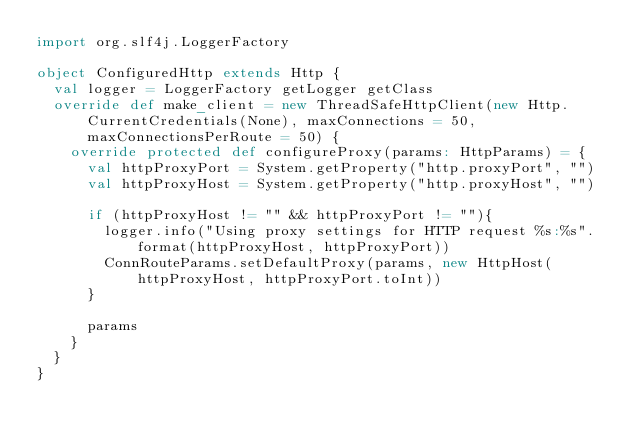Convert code to text. <code><loc_0><loc_0><loc_500><loc_500><_Scala_>import org.slf4j.LoggerFactory

object ConfiguredHttp extends Http {
  val logger = LoggerFactory getLogger getClass
  override def make_client = new ThreadSafeHttpClient(new Http.CurrentCredentials(None), maxConnections = 50, maxConnectionsPerRoute = 50) {
    override protected def configureProxy(params: HttpParams) = {
      val httpProxyPort = System.getProperty("http.proxyPort", "")
      val httpProxyHost = System.getProperty("http.proxyHost", "")

      if (httpProxyHost != "" && httpProxyPort != ""){
        logger.info("Using proxy settings for HTTP request %s:%s".format(httpProxyHost, httpProxyPort))
        ConnRouteParams.setDefaultProxy(params, new HttpHost(httpProxyHost, httpProxyPort.toInt))
      }

      params
    }
  }
}</code> 